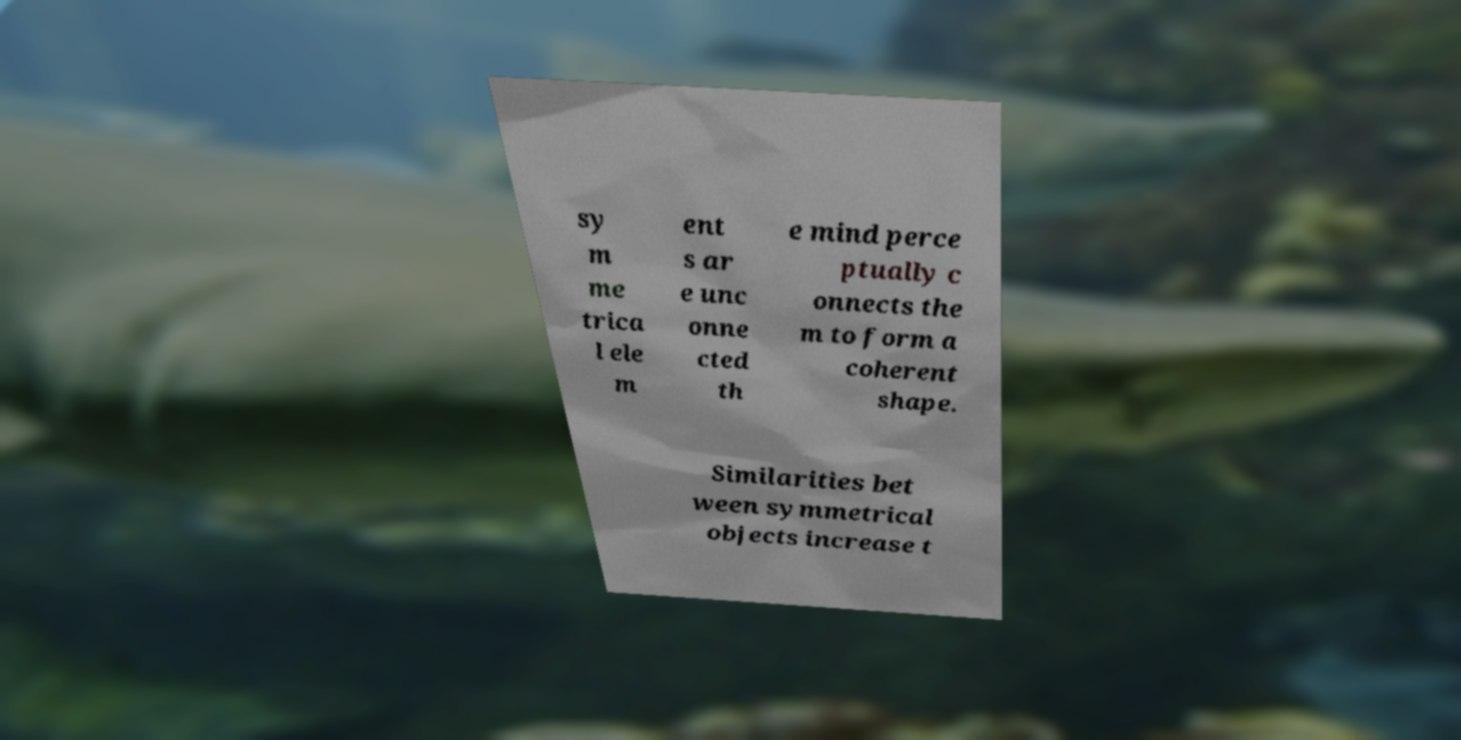Could you assist in decoding the text presented in this image and type it out clearly? sy m me trica l ele m ent s ar e unc onne cted th e mind perce ptually c onnects the m to form a coherent shape. Similarities bet ween symmetrical objects increase t 